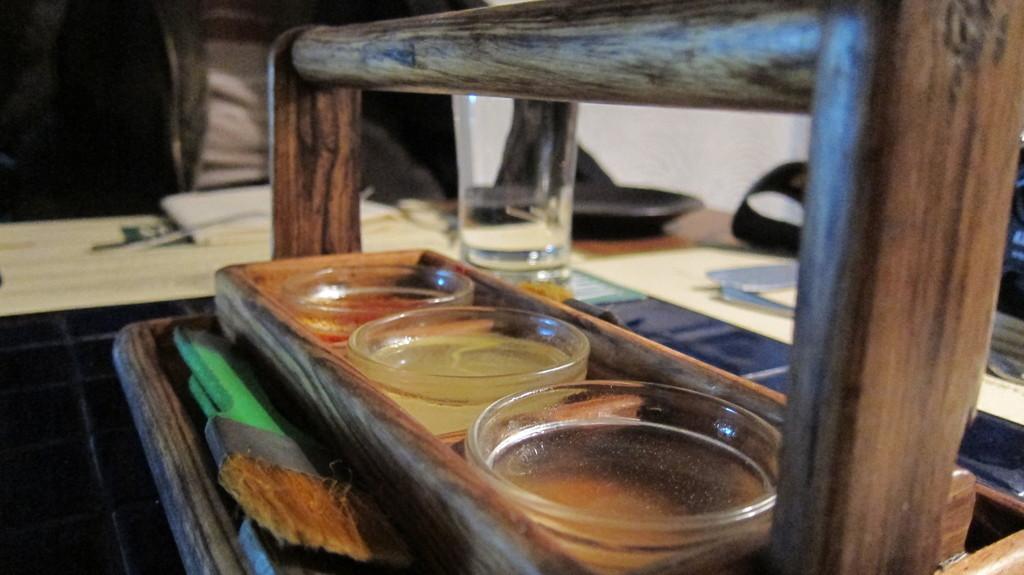Please provide a concise description of this image. In this image there is a table, on that table there is a wooden tray, in that tray there are glasses, beside the tree there is a glass, in the background there it is blurred. 